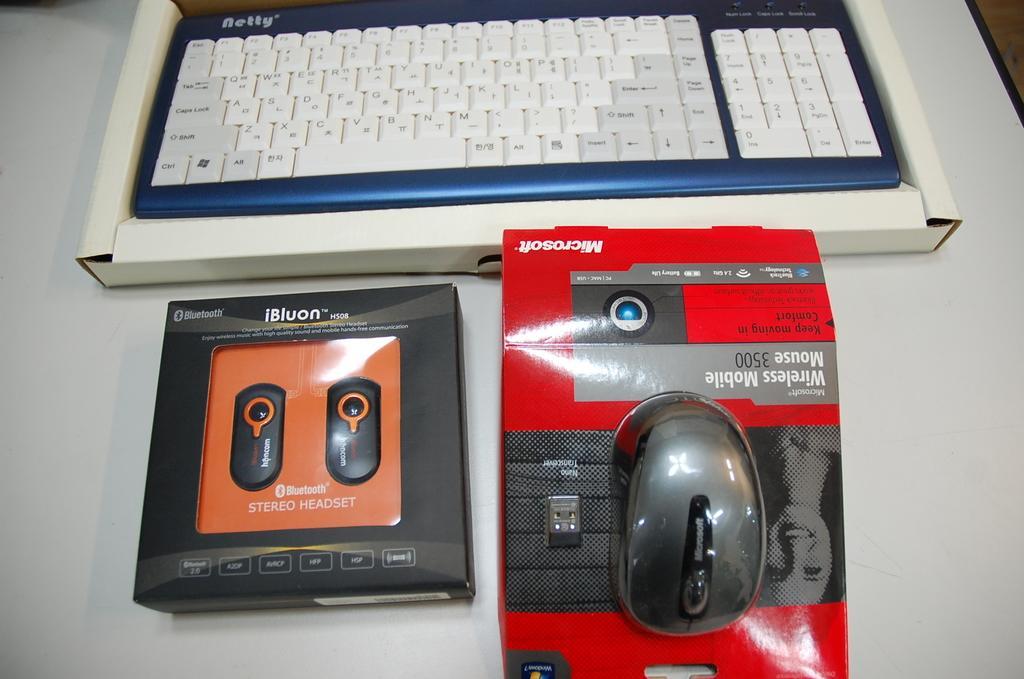Describe this image in one or two sentences. In the picture there is a keyboard, a mouse and a headset are kept on a table. 